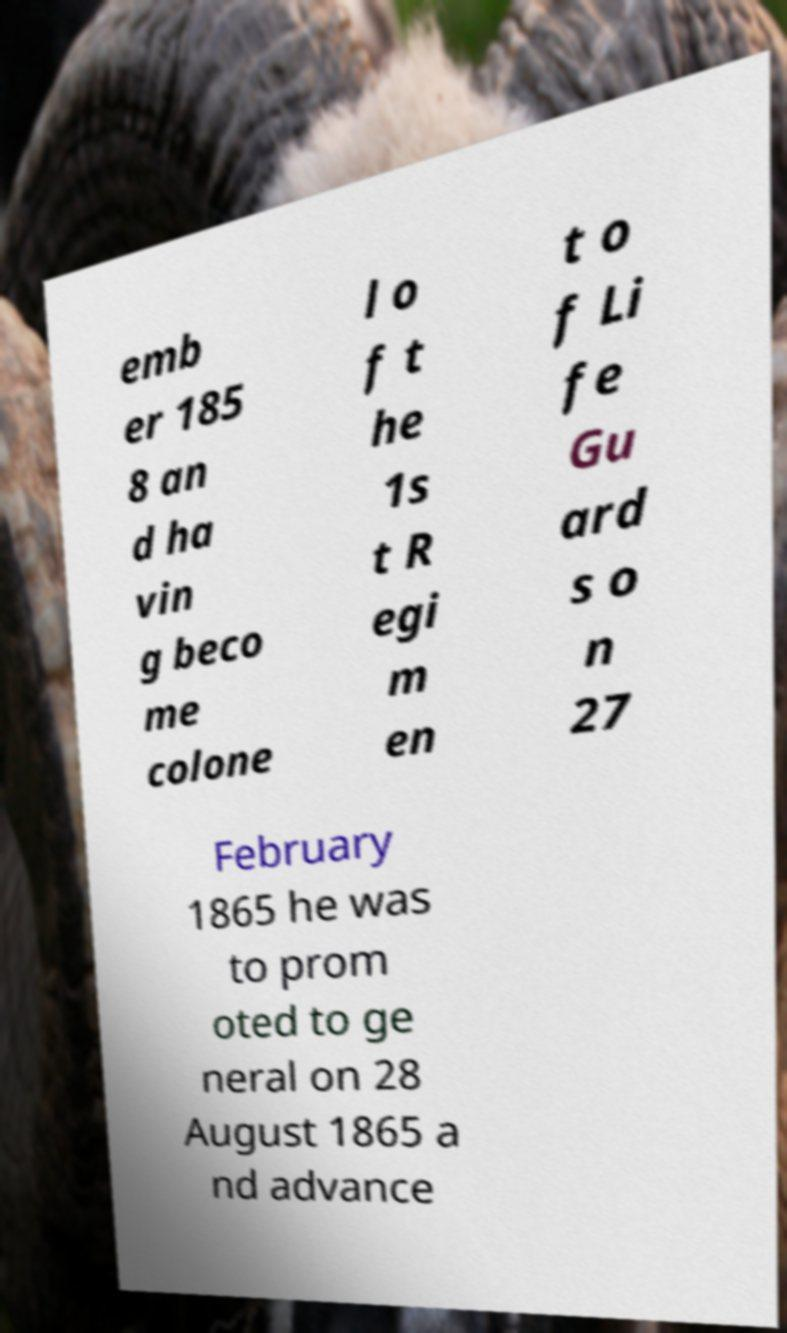There's text embedded in this image that I need extracted. Can you transcribe it verbatim? emb er 185 8 an d ha vin g beco me colone l o f t he 1s t R egi m en t o f Li fe Gu ard s o n 27 February 1865 he was to prom oted to ge neral on 28 August 1865 a nd advance 